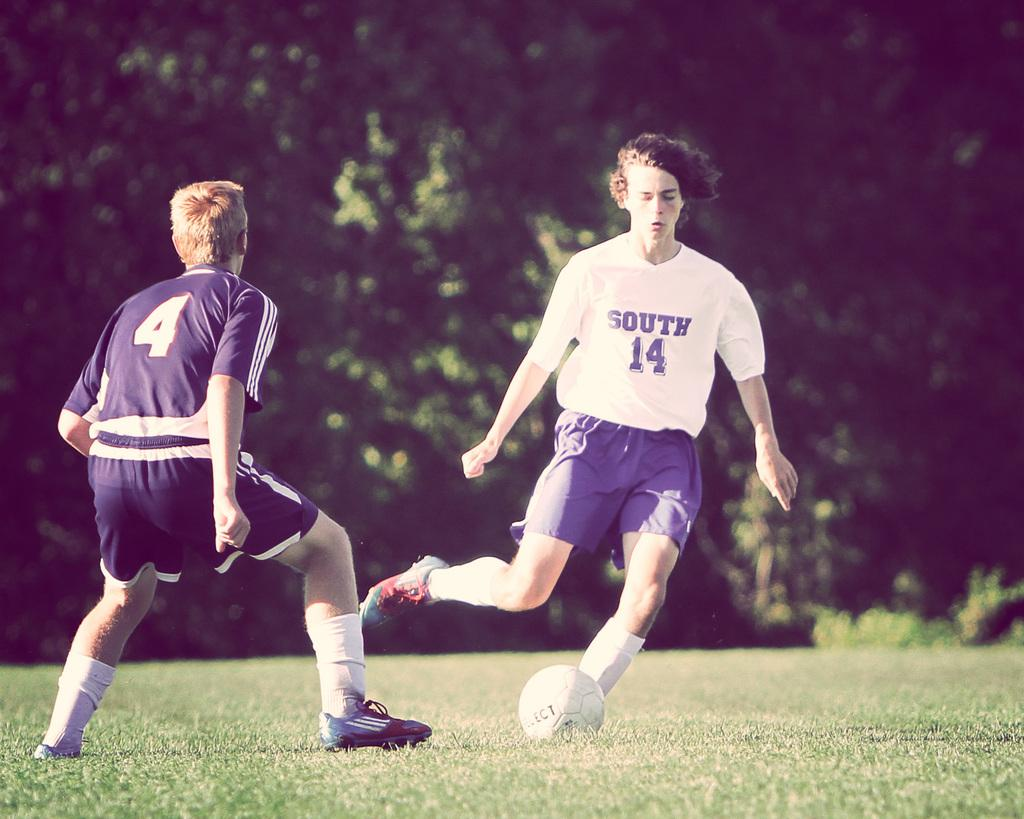<image>
Offer a succinct explanation of the picture presented. boys are wearing numbers 4 and 14 jerseys to play soccer 